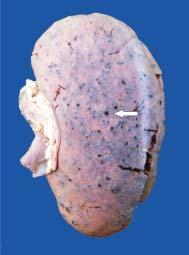s the kidney enlarged in size and weight?
Answer the question using a single word or phrase. Yes 